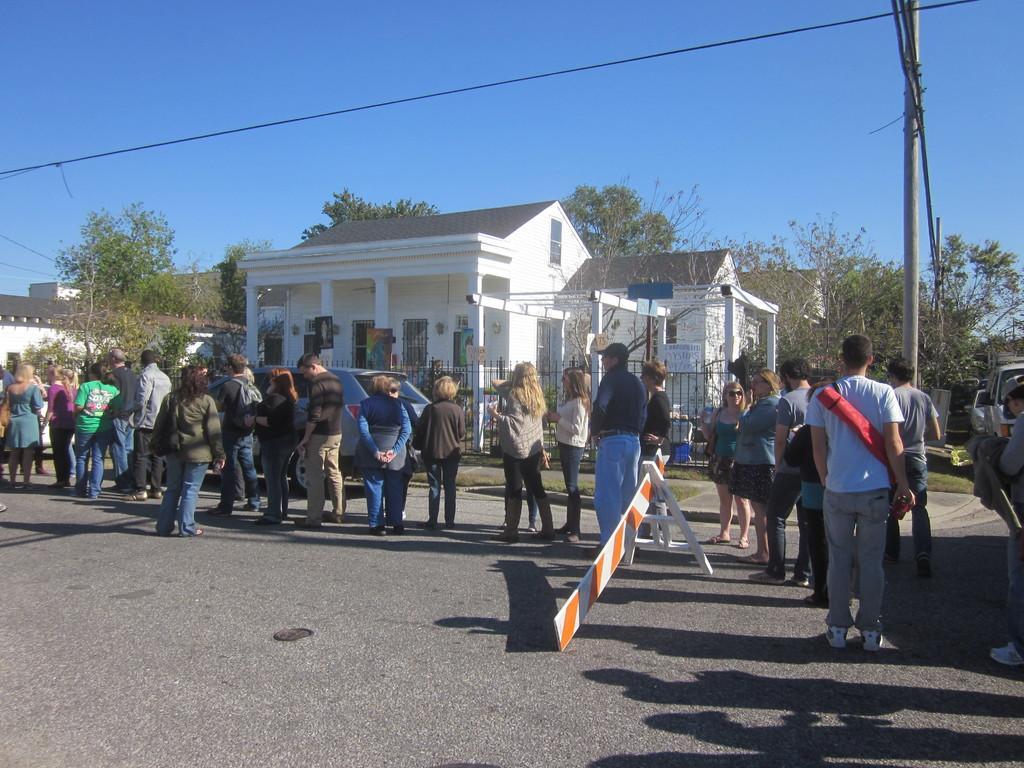Please provide a concise description of this image. In this image I can see in the middle a group of people are standing on the road. At the back side there are houses and trees, at the top it is the sky. There is a vehicle in the middle of an image. 